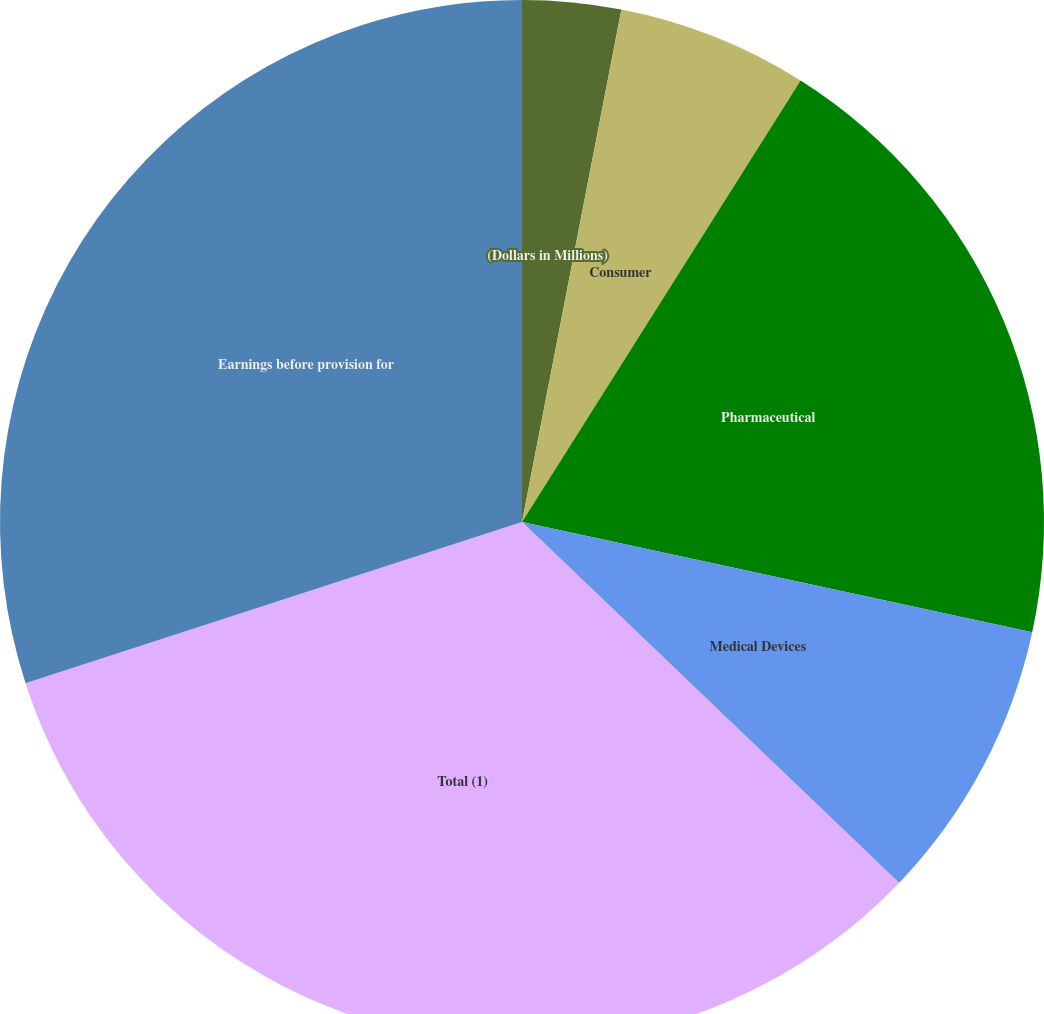Convert chart to OTSL. <chart><loc_0><loc_0><loc_500><loc_500><pie_chart><fcel>(Dollars in Millions)<fcel>Consumer<fcel>Pharmaceutical<fcel>Medical Devices<fcel>Total (1)<fcel>Earnings before provision for<nl><fcel>3.05%<fcel>5.91%<fcel>19.43%<fcel>8.76%<fcel>32.85%<fcel>30.0%<nl></chart> 